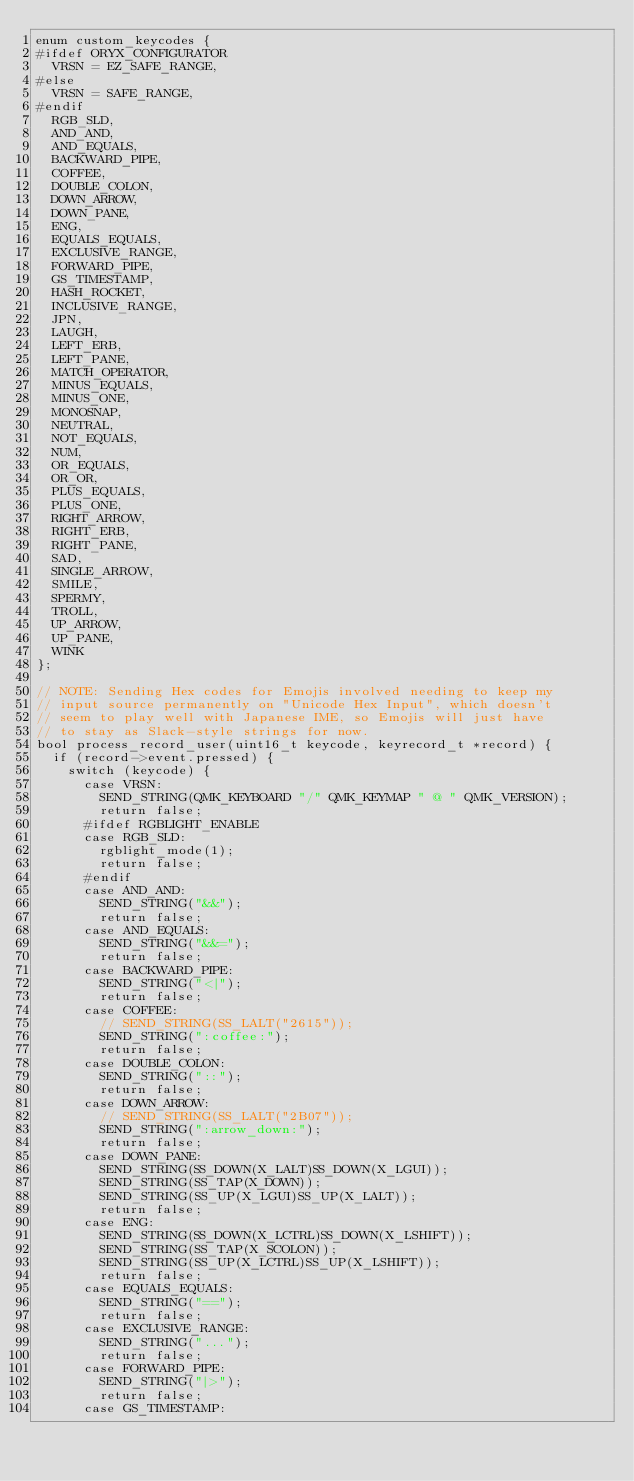<code> <loc_0><loc_0><loc_500><loc_500><_C_>enum custom_keycodes {
#ifdef ORYX_CONFIGURATOR
  VRSN = EZ_SAFE_RANGE,
#else
  VRSN = SAFE_RANGE,
#endif
  RGB_SLD,
  AND_AND,
  AND_EQUALS,
  BACKWARD_PIPE,
  COFFEE,
  DOUBLE_COLON,
  DOWN_ARROW,
  DOWN_PANE,
  ENG,
  EQUALS_EQUALS,
  EXCLUSIVE_RANGE,
  FORWARD_PIPE,
  GS_TIMESTAMP,
  HASH_ROCKET,
  INCLUSIVE_RANGE,
  JPN,
  LAUGH,
  LEFT_ERB,
  LEFT_PANE,
  MATCH_OPERATOR,
  MINUS_EQUALS,
  MINUS_ONE,
  MONOSNAP,
  NEUTRAL,
  NOT_EQUALS,
  NUM,
  OR_EQUALS,
  OR_OR,
  PLUS_EQUALS,
  PLUS_ONE,
  RIGHT_ARROW,
  RIGHT_ERB,
  RIGHT_PANE,
  SAD,
  SINGLE_ARROW,
  SMILE,
  SPERMY,
  TROLL,
  UP_ARROW,
  UP_PANE,
  WINK
};

// NOTE: Sending Hex codes for Emojis involved needing to keep my
// input source permanently on "Unicode Hex Input", which doesn't
// seem to play well with Japanese IME, so Emojis will just have
// to stay as Slack-style strings for now.
bool process_record_user(uint16_t keycode, keyrecord_t *record) {
  if (record->event.pressed) {
    switch (keycode) {
      case VRSN:
        SEND_STRING(QMK_KEYBOARD "/" QMK_KEYMAP " @ " QMK_VERSION);
        return false;
      #ifdef RGBLIGHT_ENABLE
      case RGB_SLD:
        rgblight_mode(1);
        return false;
      #endif
      case AND_AND:
        SEND_STRING("&&");
        return false;
      case AND_EQUALS:
        SEND_STRING("&&=");
        return false;
      case BACKWARD_PIPE:
        SEND_STRING("<|");
        return false;
      case COFFEE:
        // SEND_STRING(SS_LALT("2615"));
        SEND_STRING(":coffee:");
        return false;
      case DOUBLE_COLON:
        SEND_STRING("::");
        return false;
      case DOWN_ARROW:
        // SEND_STRING(SS_LALT("2B07"));
        SEND_STRING(":arrow_down:");
        return false;
      case DOWN_PANE:
        SEND_STRING(SS_DOWN(X_LALT)SS_DOWN(X_LGUI));
        SEND_STRING(SS_TAP(X_DOWN));
        SEND_STRING(SS_UP(X_LGUI)SS_UP(X_LALT));
        return false;
      case ENG:
        SEND_STRING(SS_DOWN(X_LCTRL)SS_DOWN(X_LSHIFT));
        SEND_STRING(SS_TAP(X_SCOLON));
        SEND_STRING(SS_UP(X_LCTRL)SS_UP(X_LSHIFT));
        return false;
      case EQUALS_EQUALS:
        SEND_STRING("==");
        return false;
      case EXCLUSIVE_RANGE:
        SEND_STRING("...");
        return false;
      case FORWARD_PIPE:
        SEND_STRING("|>");
        return false;
      case GS_TIMESTAMP:</code> 